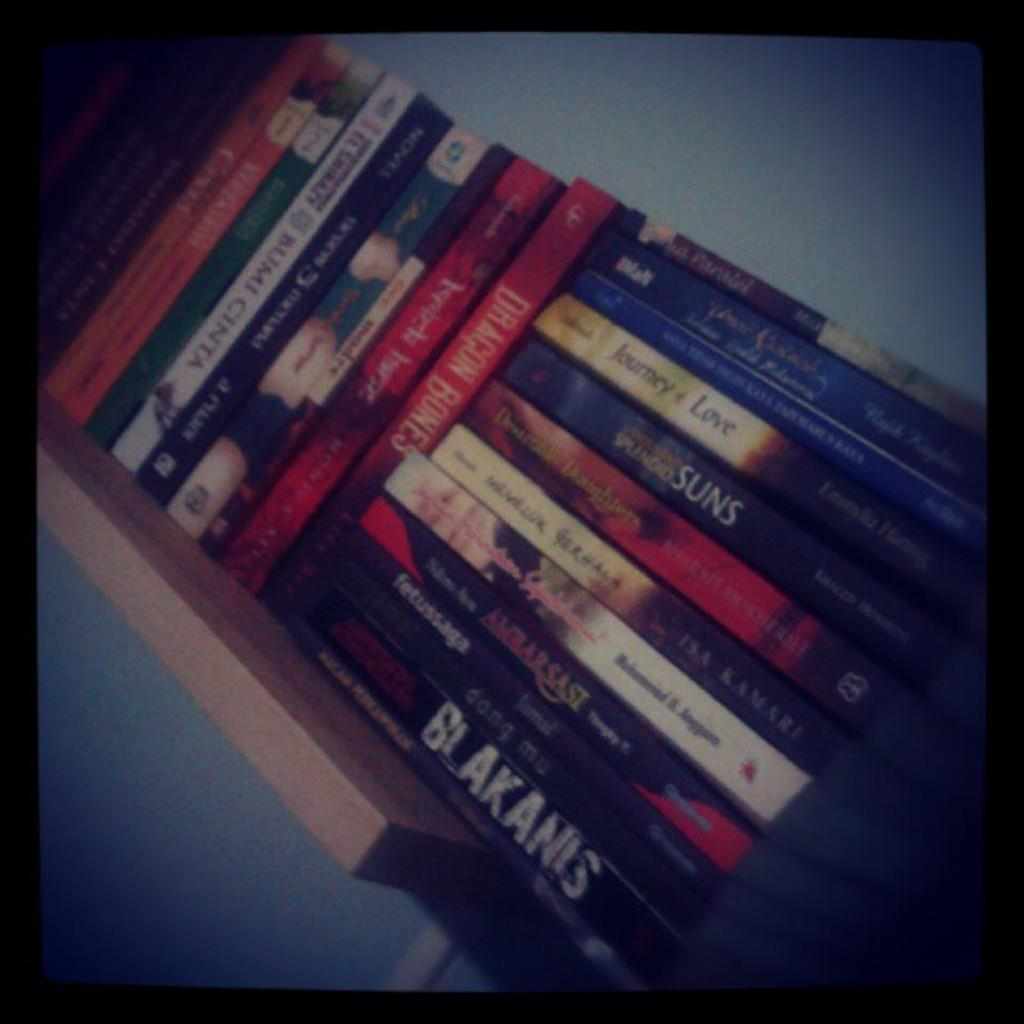Provide a one-sentence caption for the provided image. A bookshelf full of books including Journey of Love and Blakanis. 